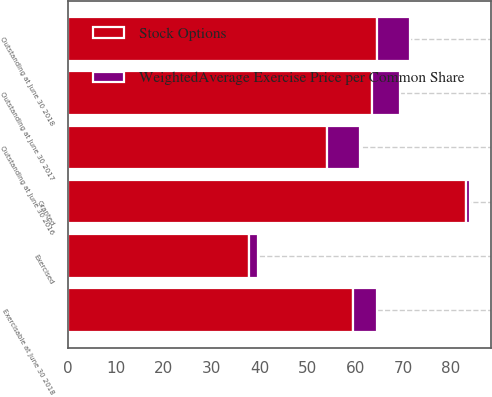Convert chart to OTSL. <chart><loc_0><loc_0><loc_500><loc_500><stacked_bar_chart><ecel><fcel>Outstanding at June 30 2016<fcel>Granted<fcel>Exercised<fcel>Outstanding at June 30 2017<fcel>Outstanding at June 30 2018<fcel>Exercisable at June 30 2018<nl><fcel>WeightedAverage Exercise Price per Common Share<fcel>7<fcel>1<fcel>2<fcel>6<fcel>7<fcel>5<nl><fcel>Stock Options<fcel>54.09<fcel>83.09<fcel>37.79<fcel>63.44<fcel>64.5<fcel>59.6<nl></chart> 